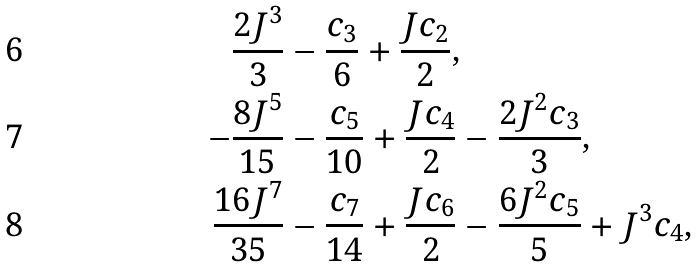Convert formula to latex. <formula><loc_0><loc_0><loc_500><loc_500>\frac { 2 J ^ { 3 } } { 3 } & - \frac { c _ { 3 } } { 6 } + \frac { J c _ { 2 } } { 2 } , \\ - \frac { 8 J ^ { 5 } } { 1 5 } & - \frac { c _ { 5 } } { 1 0 } + \frac { J c _ { 4 } } { 2 } - \frac { 2 J ^ { 2 } c _ { 3 } } { 3 } , \\ \frac { 1 6 J ^ { 7 } } { 3 5 } & - \frac { c _ { 7 } } { 1 4 } + \frac { J c _ { 6 } } { 2 } - \frac { 6 J ^ { 2 } c _ { 5 } } { 5 } + J ^ { 3 } c _ { 4 } ,</formula> 